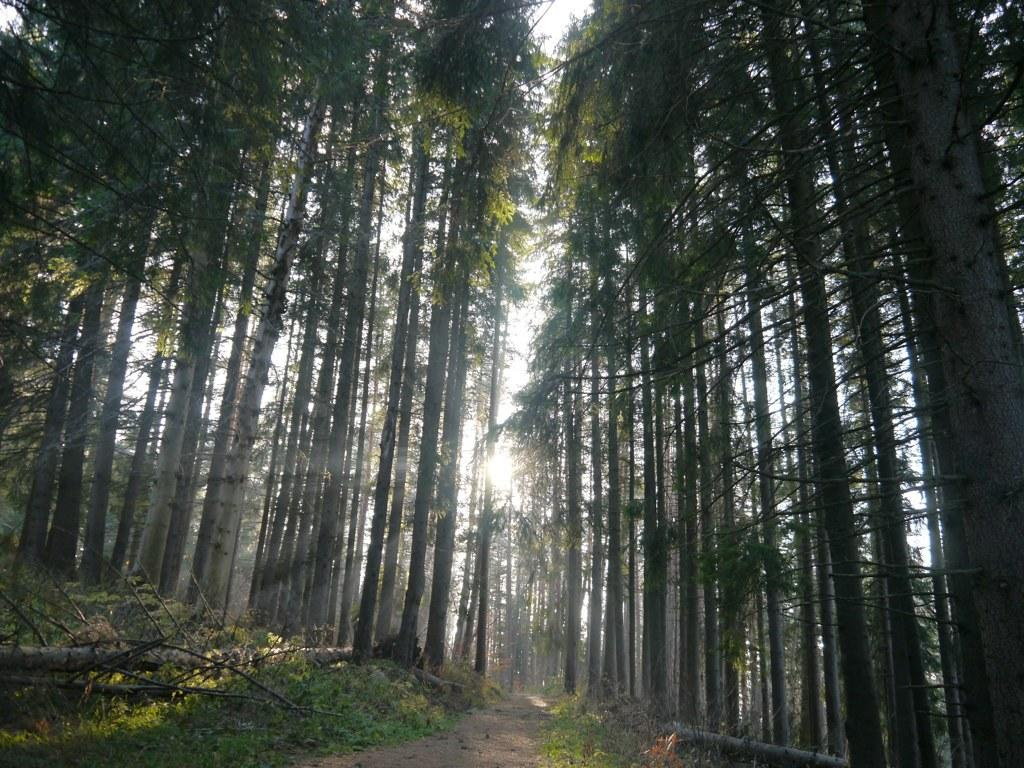What type of vegetation is present on the ground in the image? There is grass on the ground in the image. What can be seen in the background of the image? There are trees visible in the background of the image. What part of the natural environment is visible in the image? The sky is visible in the background of the image. What type of range can be seen in the image? There is no range present in the image; it features grass, trees, and the sky. What type of home is visible in the image? There is no home present in the image; it features grass, trees, and the sky. 